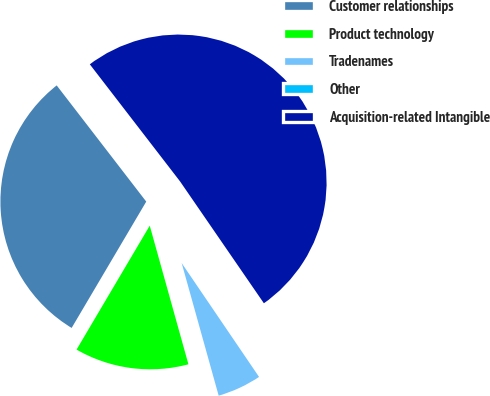Convert chart to OTSL. <chart><loc_0><loc_0><loc_500><loc_500><pie_chart><fcel>Customer relationships<fcel>Product technology<fcel>Tradenames<fcel>Other<fcel>Acquisition-related Intangible<nl><fcel>31.06%<fcel>12.82%<fcel>5.17%<fcel>0.09%<fcel>50.86%<nl></chart> 